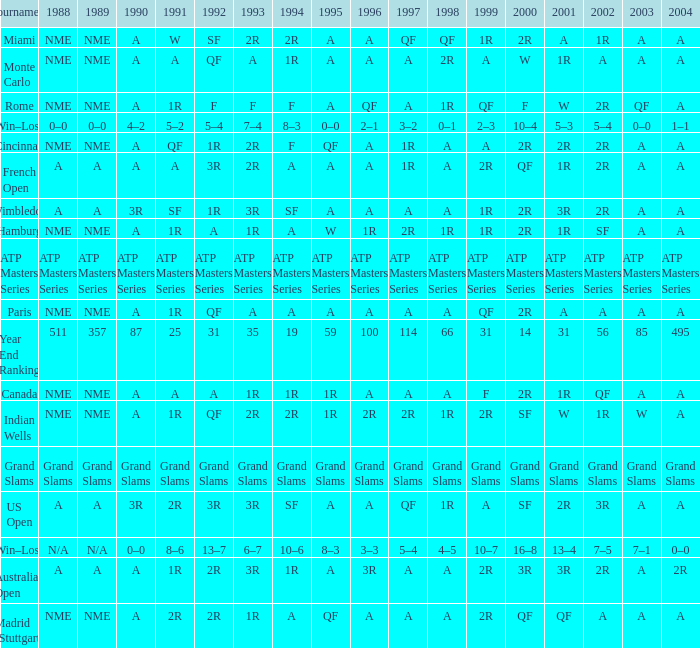What shows for 1992 when 1988 is A, at the Australian Open? 2R. 